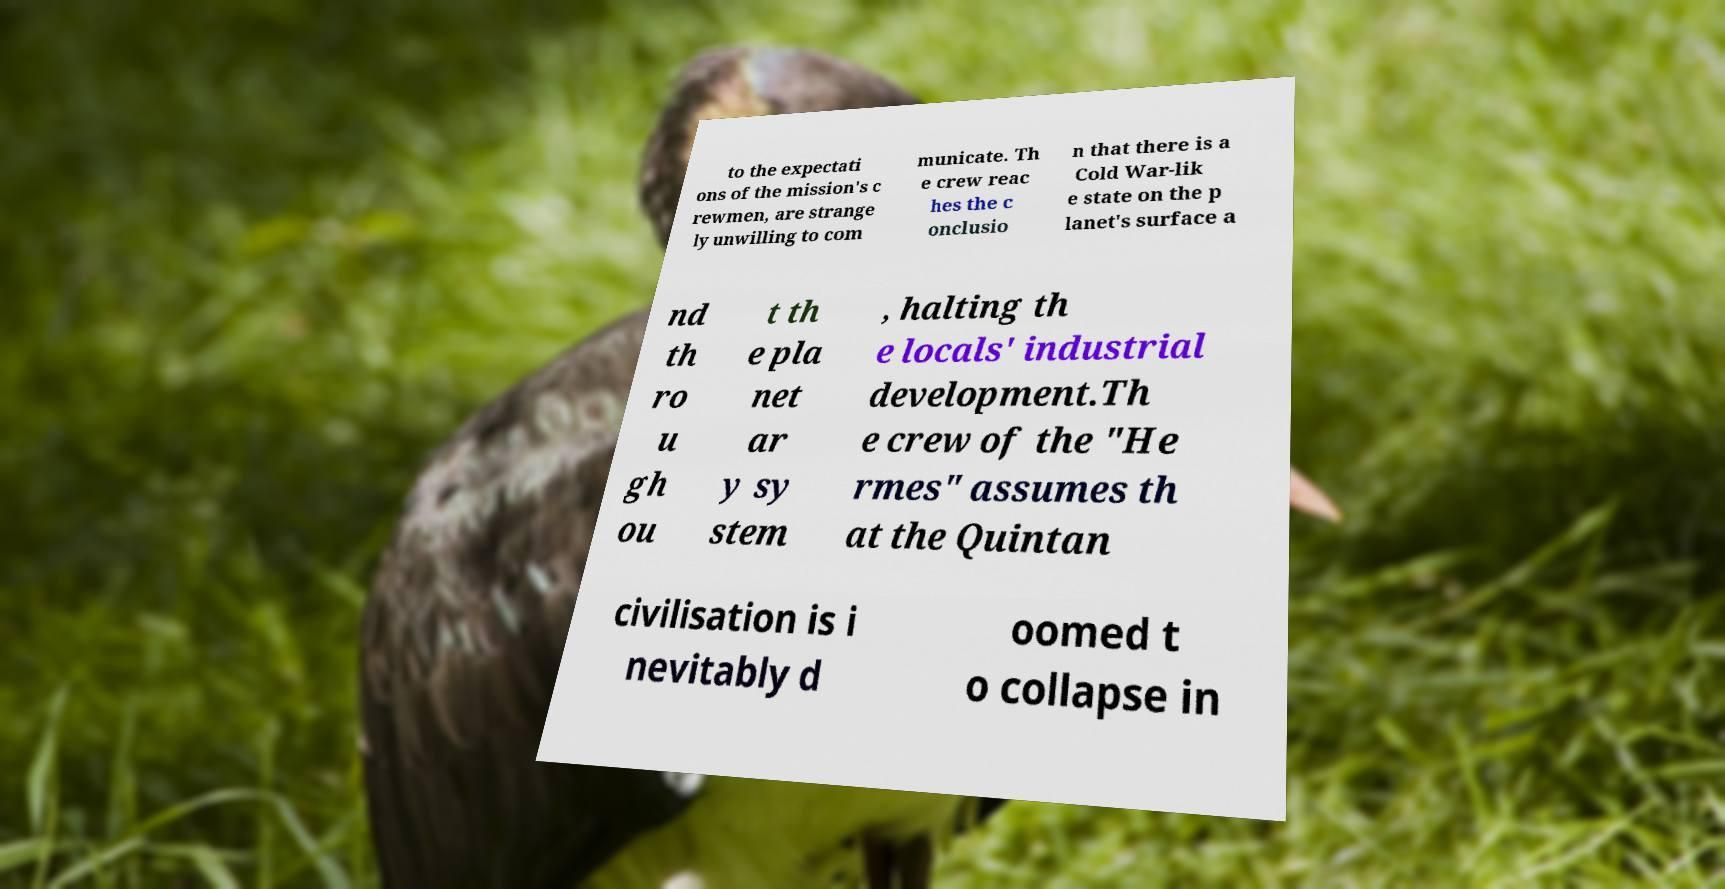What messages or text are displayed in this image? I need them in a readable, typed format. to the expectati ons of the mission's c rewmen, are strange ly unwilling to com municate. Th e crew reac hes the c onclusio n that there is a Cold War-lik e state on the p lanet's surface a nd th ro u gh ou t th e pla net ar y sy stem , halting th e locals' industrial development.Th e crew of the "He rmes" assumes th at the Quintan civilisation is i nevitably d oomed t o collapse in 